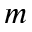Convert formula to latex. <formula><loc_0><loc_0><loc_500><loc_500>m</formula> 